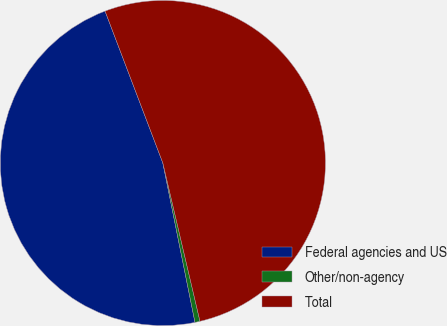Convert chart. <chart><loc_0><loc_0><loc_500><loc_500><pie_chart><fcel>Federal agencies and US<fcel>Other/non-agency<fcel>Total<nl><fcel>47.38%<fcel>0.5%<fcel>52.12%<nl></chart> 